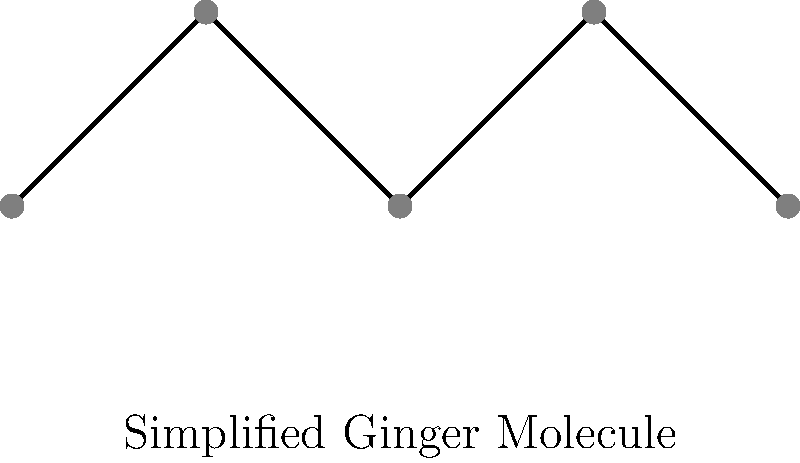The diagram shows a simplified representation of the molecular structure of a common herbal remedy used for digestive issues and inflammation. Which herb does this likely represent, and what is its primary active compound? To answer this question, let's follow these steps:

1. Observe the molecular structure:
   The diagram shows a simplified chain-like structure with alternating high and low points, representing a basic organic molecule.

2. Consider common herbal remedies:
   Many herbs are used for digestive issues and inflammation, including ginger, turmeric, and peppermint.

3. Analyze the structure in relation to known herbal compounds:
   The simplified structure resembles the backbone of gingerols and shogaols, which are the primary active compounds in ginger.

4. Identify the herb:
   Given the structure and the mentioned properties (digestive issues and inflammation), this most likely represents ginger.

5. Recall the primary active compound:
   The main active compound in ginger responsible for its therapeutic effects is gingerol.

Thus, the herb represented is likely ginger, and its primary active compound is gingerol.
Answer: Ginger; gingerol 